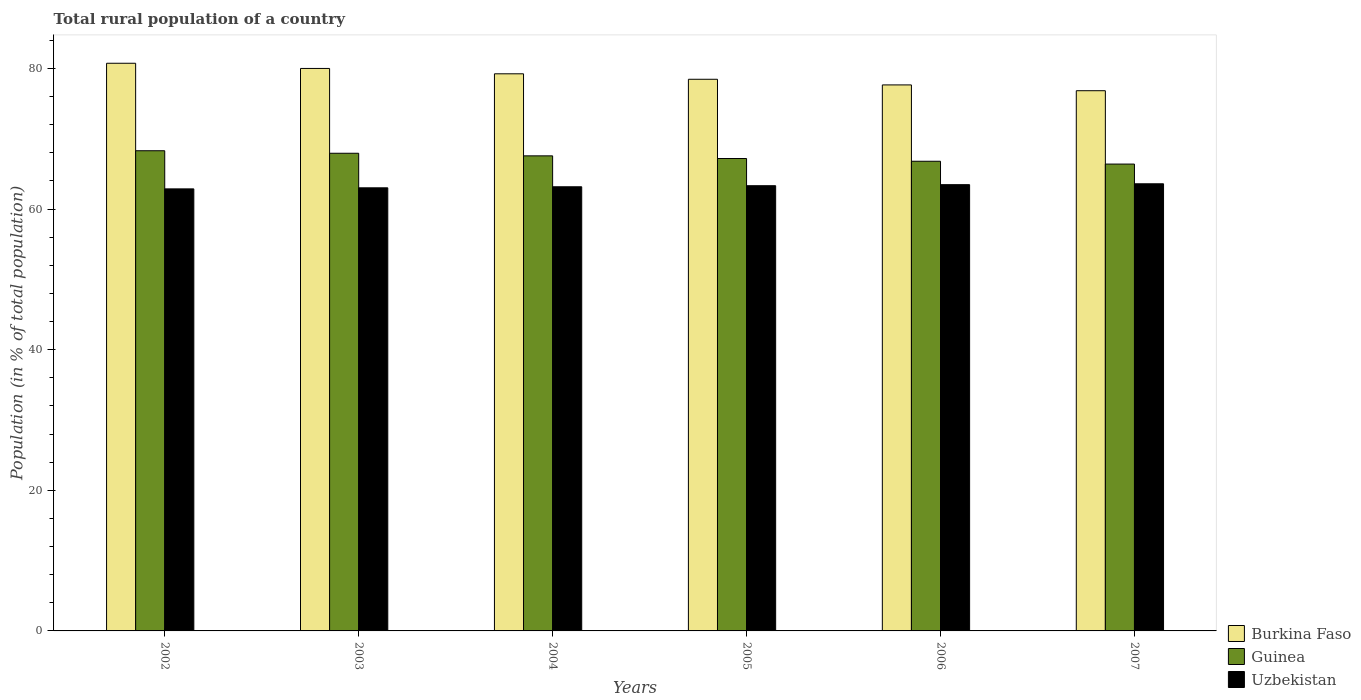How many groups of bars are there?
Ensure brevity in your answer.  6. What is the rural population in Burkina Faso in 2004?
Your answer should be very brief. 79.24. Across all years, what is the maximum rural population in Guinea?
Offer a terse response. 68.3. Across all years, what is the minimum rural population in Burkina Faso?
Your answer should be very brief. 76.84. In which year was the rural population in Uzbekistan minimum?
Provide a short and direct response. 2002. What is the total rural population in Guinea in the graph?
Offer a very short reply. 404.21. What is the difference between the rural population in Burkina Faso in 2004 and that in 2007?
Keep it short and to the point. 2.41. What is the difference between the rural population in Guinea in 2005 and the rural population in Uzbekistan in 2004?
Provide a succinct answer. 4.02. What is the average rural population in Guinea per year?
Offer a terse response. 67.37. In the year 2006, what is the difference between the rural population in Uzbekistan and rural population in Burkina Faso?
Provide a short and direct response. -14.19. What is the ratio of the rural population in Burkina Faso in 2004 to that in 2005?
Offer a very short reply. 1.01. Is the difference between the rural population in Uzbekistan in 2003 and 2006 greater than the difference between the rural population in Burkina Faso in 2003 and 2006?
Your response must be concise. No. What is the difference between the highest and the second highest rural population in Uzbekistan?
Give a very brief answer. 0.12. What is the difference between the highest and the lowest rural population in Guinea?
Provide a short and direct response. 1.89. What does the 2nd bar from the left in 2004 represents?
Your response must be concise. Guinea. What does the 2nd bar from the right in 2004 represents?
Keep it short and to the point. Guinea. Is it the case that in every year, the sum of the rural population in Uzbekistan and rural population in Guinea is greater than the rural population in Burkina Faso?
Provide a short and direct response. Yes. How many bars are there?
Your answer should be compact. 18. What is the difference between two consecutive major ticks on the Y-axis?
Make the answer very short. 20. Are the values on the major ticks of Y-axis written in scientific E-notation?
Your response must be concise. No. Does the graph contain any zero values?
Give a very brief answer. No. What is the title of the graph?
Keep it short and to the point. Total rural population of a country. What is the label or title of the Y-axis?
Make the answer very short. Population (in % of total population). What is the Population (in % of total population) in Burkina Faso in 2002?
Your answer should be compact. 80.74. What is the Population (in % of total population) of Guinea in 2002?
Give a very brief answer. 68.3. What is the Population (in % of total population) in Uzbekistan in 2002?
Your answer should be very brief. 62.87. What is the Population (in % of total population) in Burkina Faso in 2003?
Keep it short and to the point. 80. What is the Population (in % of total population) of Guinea in 2003?
Your answer should be very brief. 67.94. What is the Population (in % of total population) of Uzbekistan in 2003?
Your answer should be very brief. 63.02. What is the Population (in % of total population) in Burkina Faso in 2004?
Your response must be concise. 79.24. What is the Population (in % of total population) in Guinea in 2004?
Your answer should be very brief. 67.57. What is the Population (in % of total population) in Uzbekistan in 2004?
Your answer should be compact. 63.17. What is the Population (in % of total population) in Burkina Faso in 2005?
Your response must be concise. 78.46. What is the Population (in % of total population) in Guinea in 2005?
Your answer should be very brief. 67.19. What is the Population (in % of total population) in Uzbekistan in 2005?
Give a very brief answer. 63.32. What is the Population (in % of total population) in Burkina Faso in 2006?
Ensure brevity in your answer.  77.66. What is the Population (in % of total population) of Guinea in 2006?
Keep it short and to the point. 66.8. What is the Population (in % of total population) of Uzbekistan in 2006?
Give a very brief answer. 63.47. What is the Population (in % of total population) in Burkina Faso in 2007?
Your answer should be very brief. 76.84. What is the Population (in % of total population) in Guinea in 2007?
Your answer should be compact. 66.4. What is the Population (in % of total population) of Uzbekistan in 2007?
Provide a short and direct response. 63.6. Across all years, what is the maximum Population (in % of total population) of Burkina Faso?
Make the answer very short. 80.74. Across all years, what is the maximum Population (in % of total population) of Guinea?
Ensure brevity in your answer.  68.3. Across all years, what is the maximum Population (in % of total population) in Uzbekistan?
Provide a succinct answer. 63.6. Across all years, what is the minimum Population (in % of total population) of Burkina Faso?
Offer a terse response. 76.84. Across all years, what is the minimum Population (in % of total population) in Guinea?
Offer a very short reply. 66.4. Across all years, what is the minimum Population (in % of total population) in Uzbekistan?
Your response must be concise. 62.87. What is the total Population (in % of total population) in Burkina Faso in the graph?
Provide a short and direct response. 472.95. What is the total Population (in % of total population) of Guinea in the graph?
Keep it short and to the point. 404.21. What is the total Population (in % of total population) in Uzbekistan in the graph?
Provide a succinct answer. 379.47. What is the difference between the Population (in % of total population) of Burkina Faso in 2002 and that in 2003?
Your response must be concise. 0.74. What is the difference between the Population (in % of total population) of Guinea in 2002 and that in 2003?
Offer a terse response. 0.36. What is the difference between the Population (in % of total population) of Uzbekistan in 2002 and that in 2003?
Ensure brevity in your answer.  -0.15. What is the difference between the Population (in % of total population) of Burkina Faso in 2002 and that in 2004?
Make the answer very short. 1.5. What is the difference between the Population (in % of total population) of Guinea in 2002 and that in 2004?
Ensure brevity in your answer.  0.73. What is the difference between the Population (in % of total population) in Uzbekistan in 2002 and that in 2004?
Offer a terse response. -0.3. What is the difference between the Population (in % of total population) in Burkina Faso in 2002 and that in 2005?
Provide a short and direct response. 2.28. What is the difference between the Population (in % of total population) of Guinea in 2002 and that in 2005?
Give a very brief answer. 1.1. What is the difference between the Population (in % of total population) in Uzbekistan in 2002 and that in 2005?
Make the answer very short. -0.45. What is the difference between the Population (in % of total population) of Burkina Faso in 2002 and that in 2006?
Give a very brief answer. 3.08. What is the difference between the Population (in % of total population) in Guinea in 2002 and that in 2006?
Your answer should be compact. 1.49. What is the difference between the Population (in % of total population) in Uzbekistan in 2002 and that in 2006?
Offer a very short reply. -0.6. What is the difference between the Population (in % of total population) of Burkina Faso in 2002 and that in 2007?
Provide a short and direct response. 3.9. What is the difference between the Population (in % of total population) of Guinea in 2002 and that in 2007?
Offer a terse response. 1.89. What is the difference between the Population (in % of total population) of Uzbekistan in 2002 and that in 2007?
Your response must be concise. -0.72. What is the difference between the Population (in % of total population) of Burkina Faso in 2003 and that in 2004?
Provide a succinct answer. 0.76. What is the difference between the Population (in % of total population) of Guinea in 2003 and that in 2004?
Your response must be concise. 0.37. What is the difference between the Population (in % of total population) of Burkina Faso in 2003 and that in 2005?
Give a very brief answer. 1.54. What is the difference between the Population (in % of total population) of Guinea in 2003 and that in 2005?
Give a very brief answer. 0.75. What is the difference between the Population (in % of total population) of Uzbekistan in 2003 and that in 2005?
Make the answer very short. -0.3. What is the difference between the Population (in % of total population) of Burkina Faso in 2003 and that in 2006?
Make the answer very short. 2.34. What is the difference between the Population (in % of total population) of Guinea in 2003 and that in 2006?
Give a very brief answer. 1.14. What is the difference between the Population (in % of total population) in Uzbekistan in 2003 and that in 2006?
Your answer should be very brief. -0.45. What is the difference between the Population (in % of total population) in Burkina Faso in 2003 and that in 2007?
Offer a very short reply. 3.17. What is the difference between the Population (in % of total population) of Guinea in 2003 and that in 2007?
Make the answer very short. 1.54. What is the difference between the Population (in % of total population) of Uzbekistan in 2003 and that in 2007?
Give a very brief answer. -0.57. What is the difference between the Population (in % of total population) in Burkina Faso in 2004 and that in 2005?
Make the answer very short. 0.78. What is the difference between the Population (in % of total population) of Guinea in 2004 and that in 2005?
Offer a very short reply. 0.38. What is the difference between the Population (in % of total population) of Uzbekistan in 2004 and that in 2005?
Your answer should be compact. -0.15. What is the difference between the Population (in % of total population) in Burkina Faso in 2004 and that in 2006?
Offer a terse response. 1.58. What is the difference between the Population (in % of total population) of Guinea in 2004 and that in 2006?
Make the answer very short. 0.77. What is the difference between the Population (in % of total population) in Burkina Faso in 2004 and that in 2007?
Make the answer very short. 2.41. What is the difference between the Population (in % of total population) in Guinea in 2004 and that in 2007?
Provide a short and direct response. 1.17. What is the difference between the Population (in % of total population) in Uzbekistan in 2004 and that in 2007?
Offer a very short reply. -0.42. What is the difference between the Population (in % of total population) in Burkina Faso in 2005 and that in 2006?
Give a very brief answer. 0.8. What is the difference between the Population (in % of total population) in Guinea in 2005 and that in 2006?
Offer a very short reply. 0.39. What is the difference between the Population (in % of total population) of Burkina Faso in 2005 and that in 2007?
Give a very brief answer. 1.63. What is the difference between the Population (in % of total population) in Guinea in 2005 and that in 2007?
Give a very brief answer. 0.79. What is the difference between the Population (in % of total population) of Uzbekistan in 2005 and that in 2007?
Provide a succinct answer. -0.27. What is the difference between the Population (in % of total population) in Burkina Faso in 2006 and that in 2007?
Ensure brevity in your answer.  0.82. What is the difference between the Population (in % of total population) of Guinea in 2006 and that in 2007?
Make the answer very short. 0.4. What is the difference between the Population (in % of total population) of Uzbekistan in 2006 and that in 2007?
Provide a succinct answer. -0.12. What is the difference between the Population (in % of total population) in Burkina Faso in 2002 and the Population (in % of total population) in Guinea in 2003?
Your response must be concise. 12.8. What is the difference between the Population (in % of total population) in Burkina Faso in 2002 and the Population (in % of total population) in Uzbekistan in 2003?
Offer a terse response. 17.72. What is the difference between the Population (in % of total population) in Guinea in 2002 and the Population (in % of total population) in Uzbekistan in 2003?
Your answer should be very brief. 5.27. What is the difference between the Population (in % of total population) in Burkina Faso in 2002 and the Population (in % of total population) in Guinea in 2004?
Your response must be concise. 13.17. What is the difference between the Population (in % of total population) in Burkina Faso in 2002 and the Population (in % of total population) in Uzbekistan in 2004?
Your answer should be very brief. 17.57. What is the difference between the Population (in % of total population) of Guinea in 2002 and the Population (in % of total population) of Uzbekistan in 2004?
Make the answer very short. 5.12. What is the difference between the Population (in % of total population) of Burkina Faso in 2002 and the Population (in % of total population) of Guinea in 2005?
Provide a short and direct response. 13.55. What is the difference between the Population (in % of total population) of Burkina Faso in 2002 and the Population (in % of total population) of Uzbekistan in 2005?
Your answer should be very brief. 17.42. What is the difference between the Population (in % of total population) in Guinea in 2002 and the Population (in % of total population) in Uzbekistan in 2005?
Keep it short and to the point. 4.97. What is the difference between the Population (in % of total population) in Burkina Faso in 2002 and the Population (in % of total population) in Guinea in 2006?
Your answer should be compact. 13.94. What is the difference between the Population (in % of total population) in Burkina Faso in 2002 and the Population (in % of total population) in Uzbekistan in 2006?
Give a very brief answer. 17.27. What is the difference between the Population (in % of total population) in Guinea in 2002 and the Population (in % of total population) in Uzbekistan in 2006?
Make the answer very short. 4.82. What is the difference between the Population (in % of total population) in Burkina Faso in 2002 and the Population (in % of total population) in Guinea in 2007?
Keep it short and to the point. 14.34. What is the difference between the Population (in % of total population) in Burkina Faso in 2002 and the Population (in % of total population) in Uzbekistan in 2007?
Ensure brevity in your answer.  17.14. What is the difference between the Population (in % of total population) in Guinea in 2002 and the Population (in % of total population) in Uzbekistan in 2007?
Offer a terse response. 4.7. What is the difference between the Population (in % of total population) of Burkina Faso in 2003 and the Population (in % of total population) of Guinea in 2004?
Keep it short and to the point. 12.43. What is the difference between the Population (in % of total population) of Burkina Faso in 2003 and the Population (in % of total population) of Uzbekistan in 2004?
Keep it short and to the point. 16.83. What is the difference between the Population (in % of total population) of Guinea in 2003 and the Population (in % of total population) of Uzbekistan in 2004?
Your answer should be compact. 4.77. What is the difference between the Population (in % of total population) of Burkina Faso in 2003 and the Population (in % of total population) of Guinea in 2005?
Your answer should be very brief. 12.81. What is the difference between the Population (in % of total population) in Burkina Faso in 2003 and the Population (in % of total population) in Uzbekistan in 2005?
Keep it short and to the point. 16.68. What is the difference between the Population (in % of total population) in Guinea in 2003 and the Population (in % of total population) in Uzbekistan in 2005?
Your response must be concise. 4.62. What is the difference between the Population (in % of total population) of Burkina Faso in 2003 and the Population (in % of total population) of Guinea in 2006?
Keep it short and to the point. 13.2. What is the difference between the Population (in % of total population) of Burkina Faso in 2003 and the Population (in % of total population) of Uzbekistan in 2006?
Offer a terse response. 16.53. What is the difference between the Population (in % of total population) of Guinea in 2003 and the Population (in % of total population) of Uzbekistan in 2006?
Offer a very short reply. 4.47. What is the difference between the Population (in % of total population) of Burkina Faso in 2003 and the Population (in % of total population) of Uzbekistan in 2007?
Give a very brief answer. 16.41. What is the difference between the Population (in % of total population) in Guinea in 2003 and the Population (in % of total population) in Uzbekistan in 2007?
Make the answer very short. 4.34. What is the difference between the Population (in % of total population) of Burkina Faso in 2004 and the Population (in % of total population) of Guinea in 2005?
Make the answer very short. 12.05. What is the difference between the Population (in % of total population) in Burkina Faso in 2004 and the Population (in % of total population) in Uzbekistan in 2005?
Provide a short and direct response. 15.92. What is the difference between the Population (in % of total population) of Guinea in 2004 and the Population (in % of total population) of Uzbekistan in 2005?
Your response must be concise. 4.25. What is the difference between the Population (in % of total population) in Burkina Faso in 2004 and the Population (in % of total population) in Guinea in 2006?
Offer a terse response. 12.44. What is the difference between the Population (in % of total population) of Burkina Faso in 2004 and the Population (in % of total population) of Uzbekistan in 2006?
Ensure brevity in your answer.  15.77. What is the difference between the Population (in % of total population) of Guinea in 2004 and the Population (in % of total population) of Uzbekistan in 2006?
Your answer should be compact. 4.1. What is the difference between the Population (in % of total population) in Burkina Faso in 2004 and the Population (in % of total population) in Guinea in 2007?
Provide a short and direct response. 12.84. What is the difference between the Population (in % of total population) of Burkina Faso in 2004 and the Population (in % of total population) of Uzbekistan in 2007?
Your answer should be compact. 15.64. What is the difference between the Population (in % of total population) of Guinea in 2004 and the Population (in % of total population) of Uzbekistan in 2007?
Your response must be concise. 3.97. What is the difference between the Population (in % of total population) in Burkina Faso in 2005 and the Population (in % of total population) in Guinea in 2006?
Your response must be concise. 11.66. What is the difference between the Population (in % of total population) in Burkina Faso in 2005 and the Population (in % of total population) in Uzbekistan in 2006?
Your answer should be very brief. 14.99. What is the difference between the Population (in % of total population) of Guinea in 2005 and the Population (in % of total population) of Uzbekistan in 2006?
Give a very brief answer. 3.72. What is the difference between the Population (in % of total population) in Burkina Faso in 2005 and the Population (in % of total population) in Guinea in 2007?
Provide a short and direct response. 12.06. What is the difference between the Population (in % of total population) in Burkina Faso in 2005 and the Population (in % of total population) in Uzbekistan in 2007?
Offer a very short reply. 14.87. What is the difference between the Population (in % of total population) of Guinea in 2005 and the Population (in % of total population) of Uzbekistan in 2007?
Make the answer very short. 3.6. What is the difference between the Population (in % of total population) in Burkina Faso in 2006 and the Population (in % of total population) in Guinea in 2007?
Offer a terse response. 11.26. What is the difference between the Population (in % of total population) of Burkina Faso in 2006 and the Population (in % of total population) of Uzbekistan in 2007?
Make the answer very short. 14.06. What is the difference between the Population (in % of total population) of Guinea in 2006 and the Population (in % of total population) of Uzbekistan in 2007?
Offer a very short reply. 3.21. What is the average Population (in % of total population) of Burkina Faso per year?
Your response must be concise. 78.83. What is the average Population (in % of total population) in Guinea per year?
Your answer should be compact. 67.37. What is the average Population (in % of total population) of Uzbekistan per year?
Offer a very short reply. 63.24. In the year 2002, what is the difference between the Population (in % of total population) of Burkina Faso and Population (in % of total population) of Guinea?
Give a very brief answer. 12.44. In the year 2002, what is the difference between the Population (in % of total population) of Burkina Faso and Population (in % of total population) of Uzbekistan?
Make the answer very short. 17.87. In the year 2002, what is the difference between the Population (in % of total population) in Guinea and Population (in % of total population) in Uzbekistan?
Your response must be concise. 5.42. In the year 2003, what is the difference between the Population (in % of total population) in Burkina Faso and Population (in % of total population) in Guinea?
Offer a terse response. 12.06. In the year 2003, what is the difference between the Population (in % of total population) in Burkina Faso and Population (in % of total population) in Uzbekistan?
Give a very brief answer. 16.98. In the year 2003, what is the difference between the Population (in % of total population) in Guinea and Population (in % of total population) in Uzbekistan?
Keep it short and to the point. 4.92. In the year 2004, what is the difference between the Population (in % of total population) in Burkina Faso and Population (in % of total population) in Guinea?
Provide a succinct answer. 11.67. In the year 2004, what is the difference between the Population (in % of total population) of Burkina Faso and Population (in % of total population) of Uzbekistan?
Provide a short and direct response. 16.07. In the year 2004, what is the difference between the Population (in % of total population) of Guinea and Population (in % of total population) of Uzbekistan?
Your answer should be compact. 4.4. In the year 2005, what is the difference between the Population (in % of total population) in Burkina Faso and Population (in % of total population) in Guinea?
Offer a very short reply. 11.27. In the year 2005, what is the difference between the Population (in % of total population) of Burkina Faso and Population (in % of total population) of Uzbekistan?
Offer a very short reply. 15.14. In the year 2005, what is the difference between the Population (in % of total population) of Guinea and Population (in % of total population) of Uzbekistan?
Give a very brief answer. 3.87. In the year 2006, what is the difference between the Population (in % of total population) of Burkina Faso and Population (in % of total population) of Guinea?
Give a very brief answer. 10.86. In the year 2006, what is the difference between the Population (in % of total population) in Burkina Faso and Population (in % of total population) in Uzbekistan?
Offer a terse response. 14.19. In the year 2006, what is the difference between the Population (in % of total population) of Guinea and Population (in % of total population) of Uzbekistan?
Provide a short and direct response. 3.33. In the year 2007, what is the difference between the Population (in % of total population) in Burkina Faso and Population (in % of total population) in Guinea?
Keep it short and to the point. 10.43. In the year 2007, what is the difference between the Population (in % of total population) in Burkina Faso and Population (in % of total population) in Uzbekistan?
Your answer should be compact. 13.24. In the year 2007, what is the difference between the Population (in % of total population) of Guinea and Population (in % of total population) of Uzbekistan?
Your answer should be compact. 2.81. What is the ratio of the Population (in % of total population) in Burkina Faso in 2002 to that in 2003?
Your answer should be compact. 1.01. What is the ratio of the Population (in % of total population) in Guinea in 2002 to that in 2003?
Give a very brief answer. 1.01. What is the ratio of the Population (in % of total population) in Uzbekistan in 2002 to that in 2003?
Your answer should be very brief. 1. What is the ratio of the Population (in % of total population) of Burkina Faso in 2002 to that in 2004?
Give a very brief answer. 1.02. What is the ratio of the Population (in % of total population) of Guinea in 2002 to that in 2004?
Your answer should be compact. 1.01. What is the ratio of the Population (in % of total population) of Uzbekistan in 2002 to that in 2004?
Offer a very short reply. 1. What is the ratio of the Population (in % of total population) of Burkina Faso in 2002 to that in 2005?
Provide a succinct answer. 1.03. What is the ratio of the Population (in % of total population) of Guinea in 2002 to that in 2005?
Ensure brevity in your answer.  1.02. What is the ratio of the Population (in % of total population) in Burkina Faso in 2002 to that in 2006?
Offer a terse response. 1.04. What is the ratio of the Population (in % of total population) of Guinea in 2002 to that in 2006?
Your answer should be compact. 1.02. What is the ratio of the Population (in % of total population) of Uzbekistan in 2002 to that in 2006?
Your answer should be very brief. 0.99. What is the ratio of the Population (in % of total population) in Burkina Faso in 2002 to that in 2007?
Your answer should be very brief. 1.05. What is the ratio of the Population (in % of total population) of Guinea in 2002 to that in 2007?
Keep it short and to the point. 1.03. What is the ratio of the Population (in % of total population) of Burkina Faso in 2003 to that in 2004?
Give a very brief answer. 1.01. What is the ratio of the Population (in % of total population) of Guinea in 2003 to that in 2004?
Keep it short and to the point. 1.01. What is the ratio of the Population (in % of total population) of Uzbekistan in 2003 to that in 2004?
Your answer should be compact. 1. What is the ratio of the Population (in % of total population) of Burkina Faso in 2003 to that in 2005?
Offer a very short reply. 1.02. What is the ratio of the Population (in % of total population) of Guinea in 2003 to that in 2005?
Your answer should be very brief. 1.01. What is the ratio of the Population (in % of total population) of Burkina Faso in 2003 to that in 2006?
Keep it short and to the point. 1.03. What is the ratio of the Population (in % of total population) of Guinea in 2003 to that in 2006?
Offer a terse response. 1.02. What is the ratio of the Population (in % of total population) of Uzbekistan in 2003 to that in 2006?
Give a very brief answer. 0.99. What is the ratio of the Population (in % of total population) in Burkina Faso in 2003 to that in 2007?
Make the answer very short. 1.04. What is the ratio of the Population (in % of total population) of Guinea in 2003 to that in 2007?
Ensure brevity in your answer.  1.02. What is the ratio of the Population (in % of total population) in Burkina Faso in 2004 to that in 2005?
Your answer should be very brief. 1.01. What is the ratio of the Population (in % of total population) in Guinea in 2004 to that in 2005?
Your answer should be compact. 1.01. What is the ratio of the Population (in % of total population) of Burkina Faso in 2004 to that in 2006?
Offer a very short reply. 1.02. What is the ratio of the Population (in % of total population) in Guinea in 2004 to that in 2006?
Make the answer very short. 1.01. What is the ratio of the Population (in % of total population) in Burkina Faso in 2004 to that in 2007?
Keep it short and to the point. 1.03. What is the ratio of the Population (in % of total population) of Guinea in 2004 to that in 2007?
Offer a terse response. 1.02. What is the ratio of the Population (in % of total population) in Uzbekistan in 2004 to that in 2007?
Provide a succinct answer. 0.99. What is the ratio of the Population (in % of total population) of Burkina Faso in 2005 to that in 2006?
Your answer should be very brief. 1.01. What is the ratio of the Population (in % of total population) in Uzbekistan in 2005 to that in 2006?
Make the answer very short. 1. What is the ratio of the Population (in % of total population) in Burkina Faso in 2005 to that in 2007?
Your response must be concise. 1.02. What is the ratio of the Population (in % of total population) of Guinea in 2005 to that in 2007?
Your answer should be compact. 1.01. What is the ratio of the Population (in % of total population) of Uzbekistan in 2005 to that in 2007?
Make the answer very short. 1. What is the ratio of the Population (in % of total population) of Burkina Faso in 2006 to that in 2007?
Ensure brevity in your answer.  1.01. What is the ratio of the Population (in % of total population) of Uzbekistan in 2006 to that in 2007?
Make the answer very short. 1. What is the difference between the highest and the second highest Population (in % of total population) in Burkina Faso?
Keep it short and to the point. 0.74. What is the difference between the highest and the second highest Population (in % of total population) in Guinea?
Offer a very short reply. 0.36. What is the difference between the highest and the second highest Population (in % of total population) of Uzbekistan?
Offer a terse response. 0.12. What is the difference between the highest and the lowest Population (in % of total population) in Burkina Faso?
Offer a very short reply. 3.9. What is the difference between the highest and the lowest Population (in % of total population) in Guinea?
Give a very brief answer. 1.89. What is the difference between the highest and the lowest Population (in % of total population) of Uzbekistan?
Offer a very short reply. 0.72. 